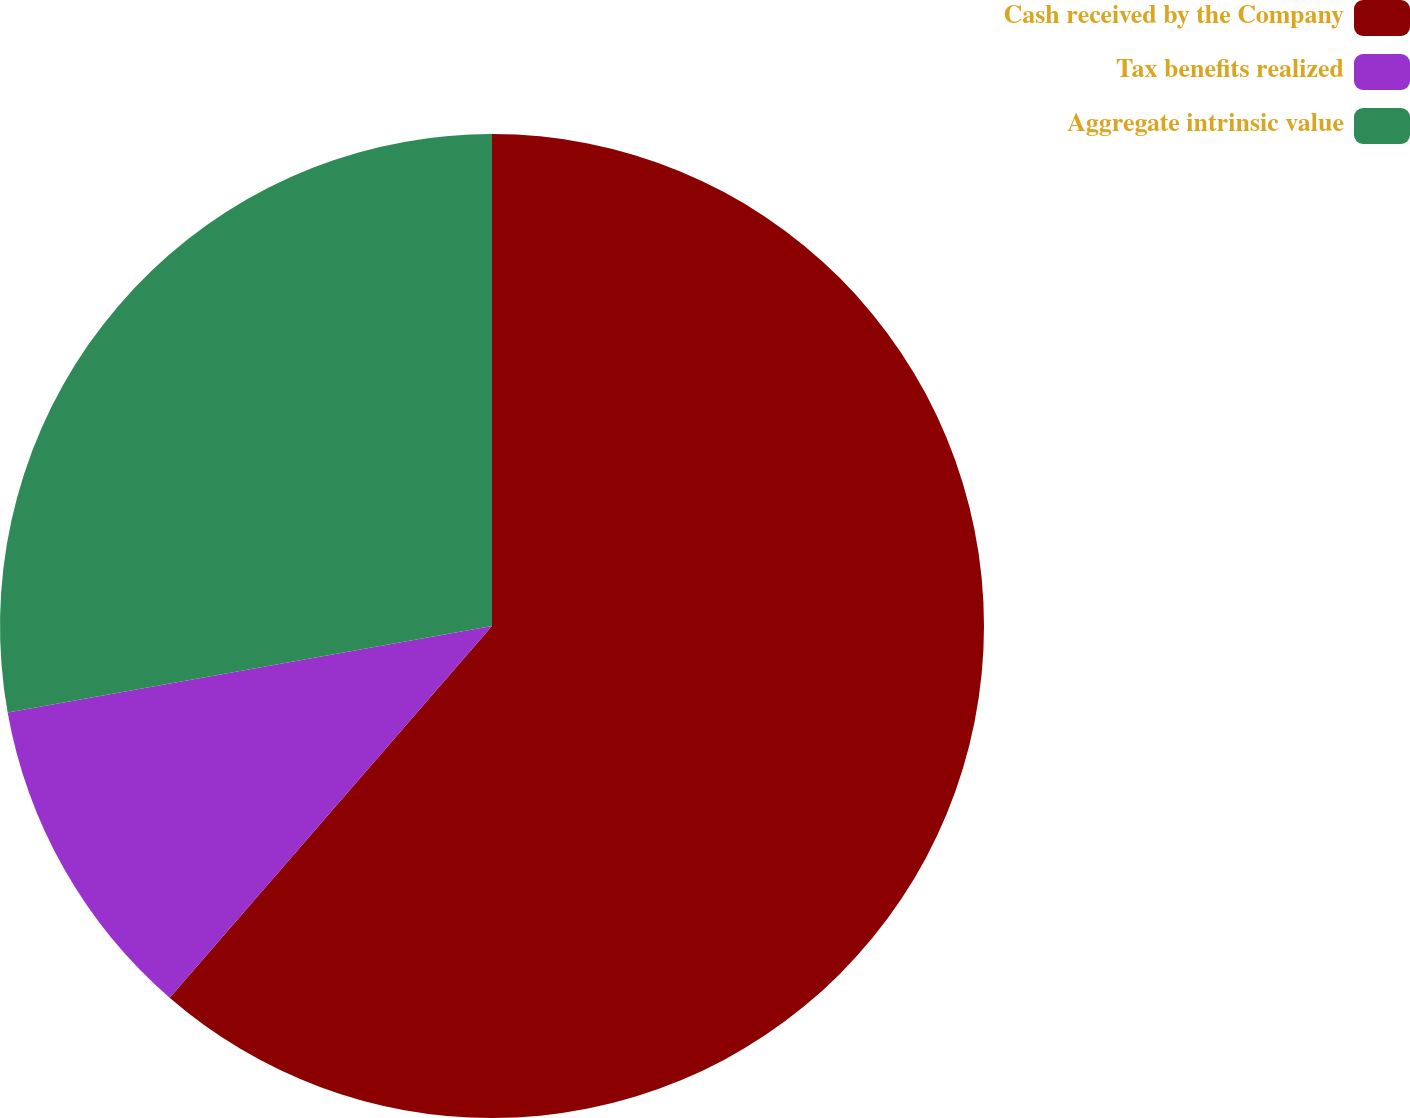<chart> <loc_0><loc_0><loc_500><loc_500><pie_chart><fcel>Cash received by the Company<fcel>Tax benefits realized<fcel>Aggregate intrinsic value<nl><fcel>61.37%<fcel>10.82%<fcel>27.81%<nl></chart> 